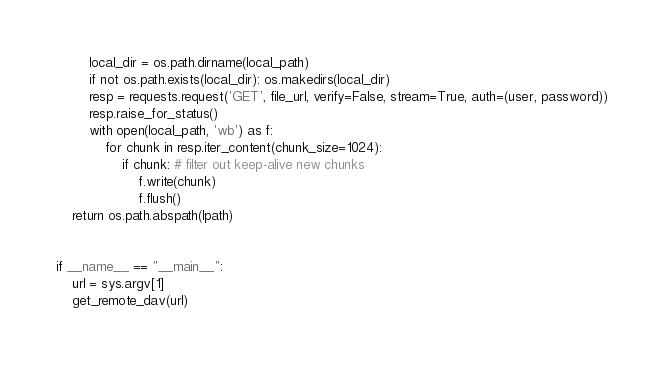Convert code to text. <code><loc_0><loc_0><loc_500><loc_500><_Python_>        local_dir = os.path.dirname(local_path)
        if not os.path.exists(local_dir): os.makedirs(local_dir)
        resp = requests.request('GET', file_url, verify=False, stream=True, auth=(user, password))
        resp.raise_for_status()
        with open(local_path, 'wb') as f:
            for chunk in resp.iter_content(chunk_size=1024):
                if chunk: # filter out keep-alive new chunks
                    f.write(chunk)
                    f.flush()
    return os.path.abspath(lpath)


if __name__ == "__main__":
    url = sys.argv[1]
    get_remote_dav(url)
</code> 